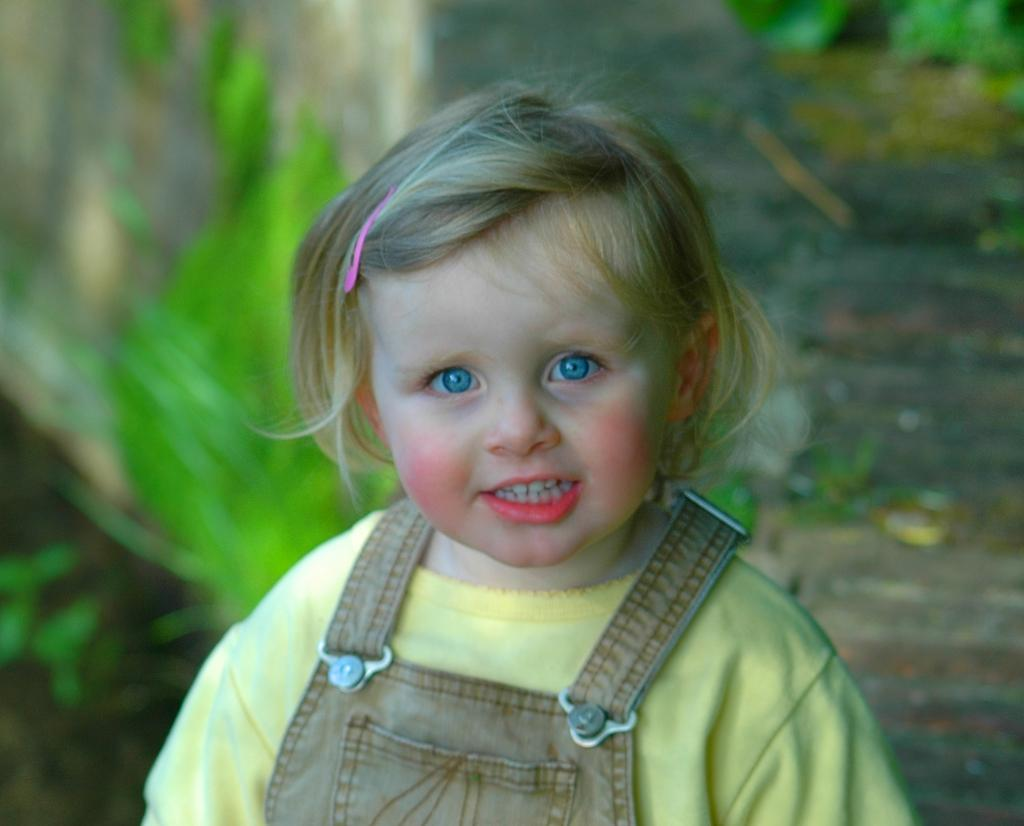Who is the main subject in the image? There is a girl in the image. What is the girl wearing? The girl is wearing a yellow shirt. What expression does the girl have? The girl is smiling. How would you describe the background of the girl? The background of the girl is blurred. What type of army is visible in the background of the image? There is no army present in the image; the background is blurred and does not show any specific objects or subjects. 